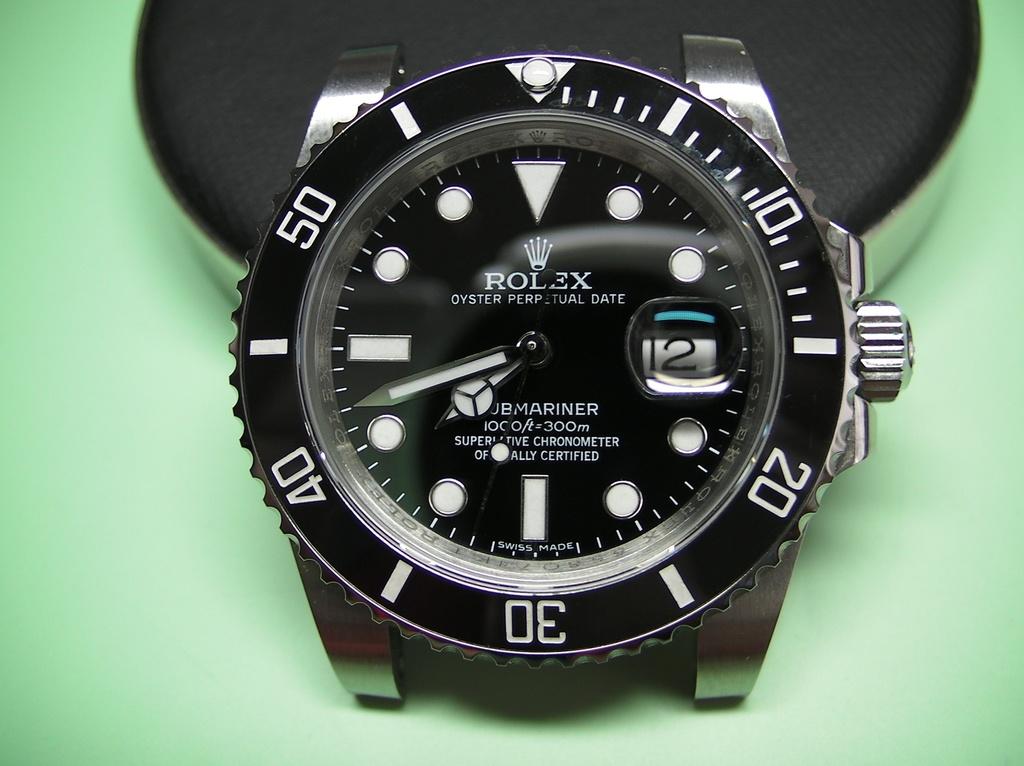What brand of watch it this?
Your answer should be very brief. Rolex. 